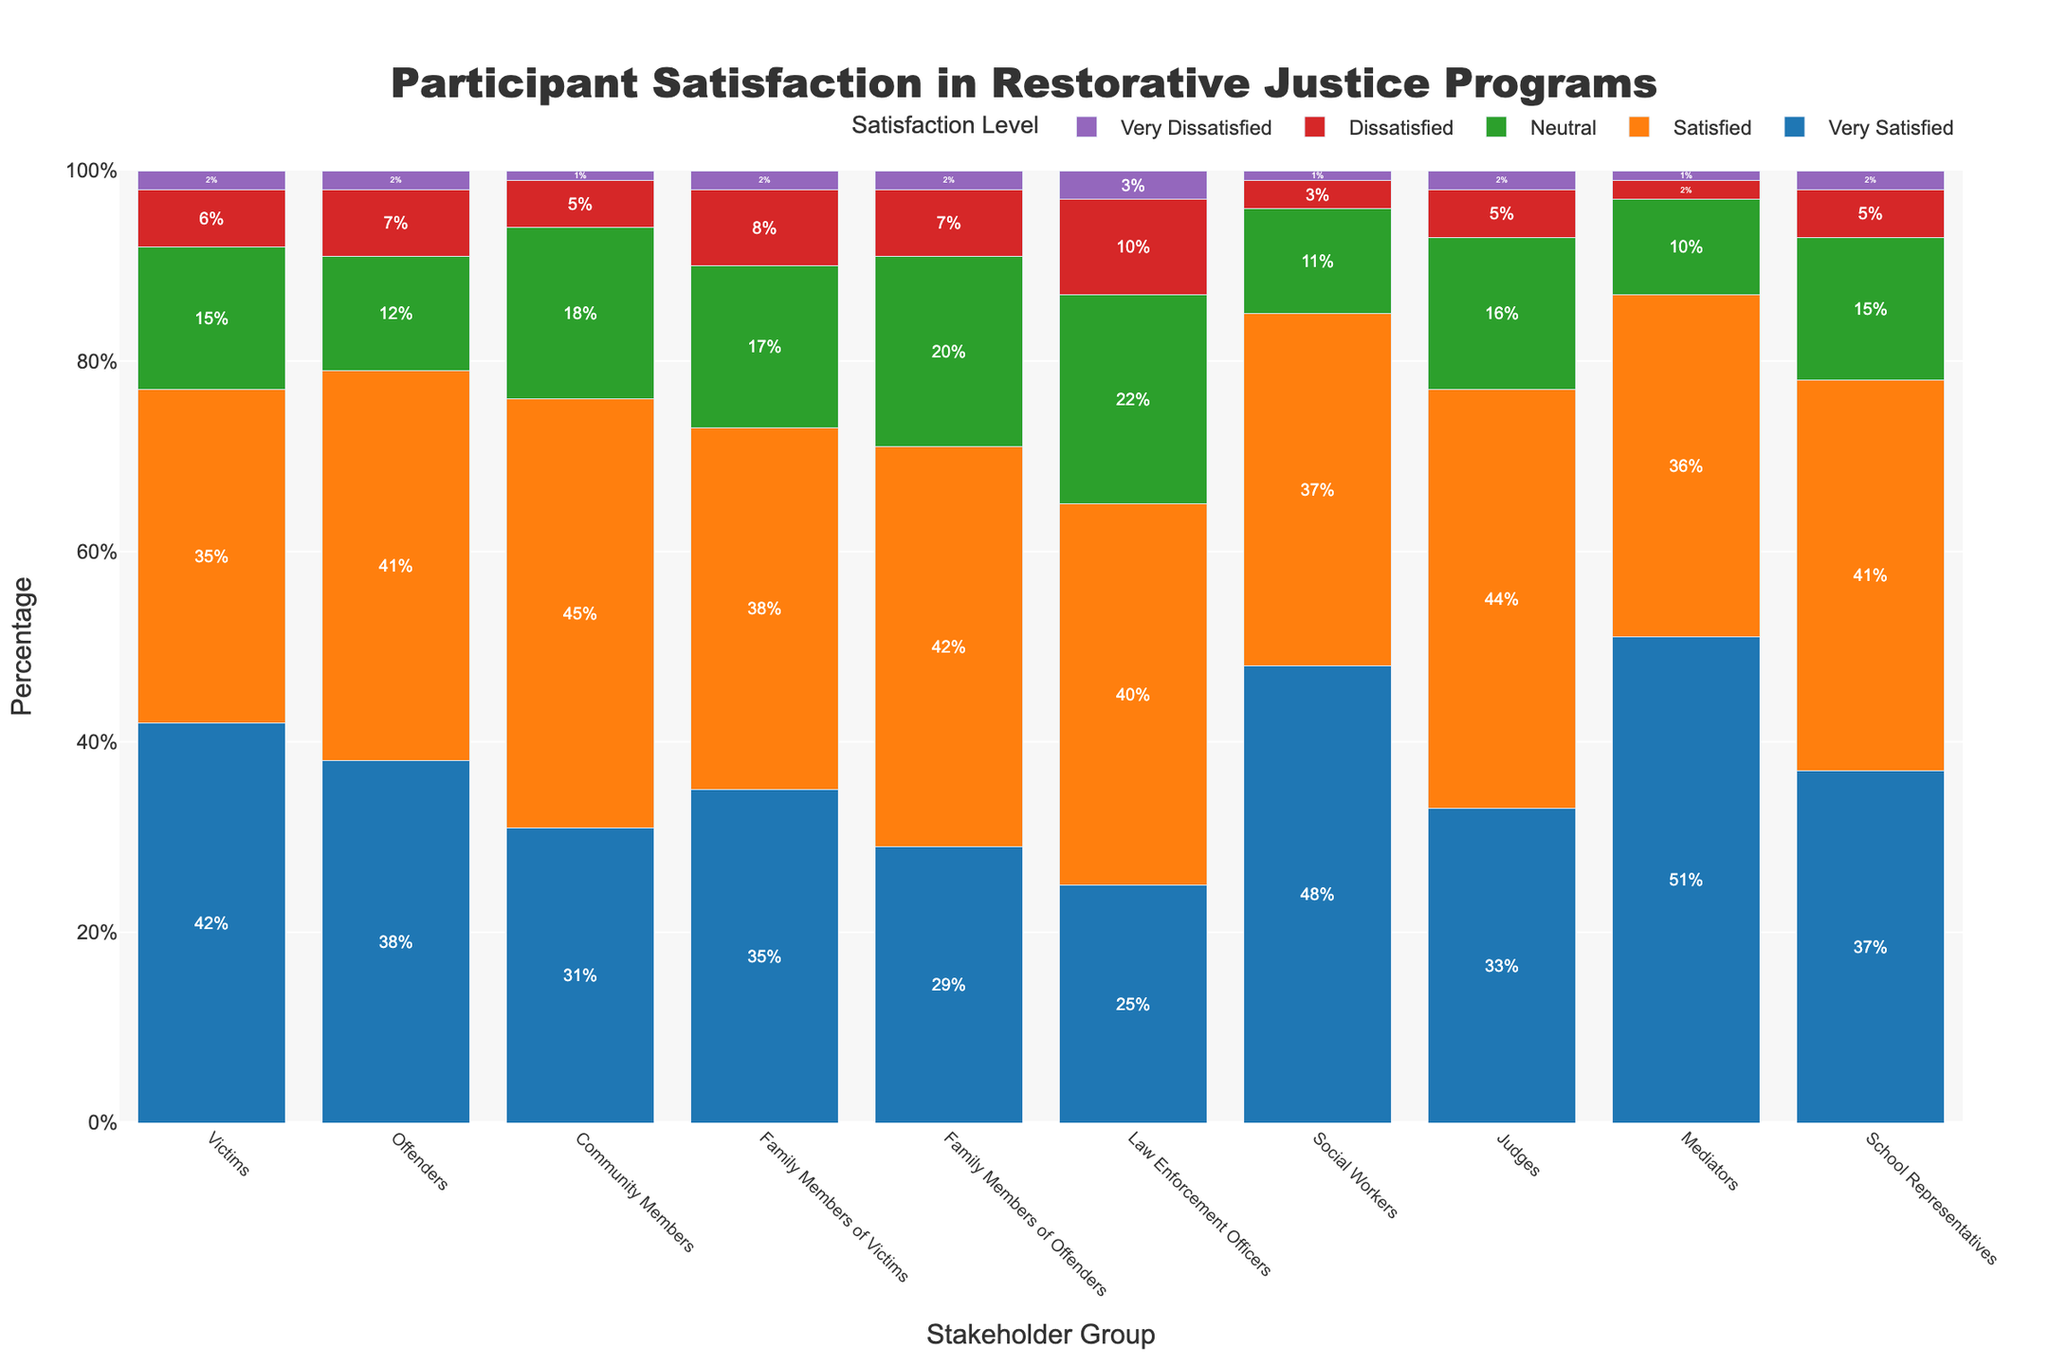What percentage of social workers are either very satisfied or satisfied? Social workers have 48% very satisfied and 37% satisfied. Adding these together gives 48 + 37 = 85%.
Answer: 85% Which stakeholder group has the highest percentage of very dissatisfied participants? Compare the percentages of "Very Dissatisfied" across all stakeholder groups. Law enforcement officers have the highest with 3%.
Answer: Law Enforcement Officers What is the difference in the percentage of "Neutral" satisfaction between victims and offenders? The victims have 15% neutral, and offenders have 12% neutral. The difference is 15 - 12 = 3%.
Answer: 3% Which two stakeholder groups have the exact same percentage of "Very Dissatisfied" participants? Both victims and offenders have 2% very dissatisfied.
Answer: Victims and Offenders Between community members and judges, which group has a higher percentage of satisfied participants and by how much? Community members have 45% satisfied, while judges have 44% satisfied. The difference is 45 - 44 = 1%.
Answer: Community Members, 1% Calculate the average percentage of "Dissatisfied" participants across all stakeholder groups. Add up the percentages of "Dissatisfied" participants from all groups and divide by the number of groups. (6+7+5+8+7+10+3+5+2+5)/10 = 5.8%.
Answer: 5.8% Do mediators have a lower percentage of very satisfied participants compared to social workers? Mediators have 51% very satisfied, while social workers have 48% very satisfied. 51% is not lower than 48%, so the answer is no.
Answer: No Which satisfaction level is most common among victims? Looking at the percentages for victims: Very Satisfied (42%), Satisfied (35%), Neutral (15%), Dissatisfied (6%), Very Dissatisfied (2%), the highest is Very Satisfied.
Answer: Very Satisfied What is the total percentage of participants who are either very dissatisfied or dissatisfied among law enforcement officers? Law enforcement officers have 10% dissatisfied and 3% very dissatisfied. Adding these together gives 10 + 3 = 13%.
Answer: 13% Who has a higher combined percentage of very satisfied and satisfied participants, judges or school representatives? Judges: Very Satisfied (33%) + Satisfied (44%) = 77%; School Representatives: Very Satisfied (37%) + Satisfied (41%) = 78%. School representatives have a higher percentage.
Answer: School Representatives 